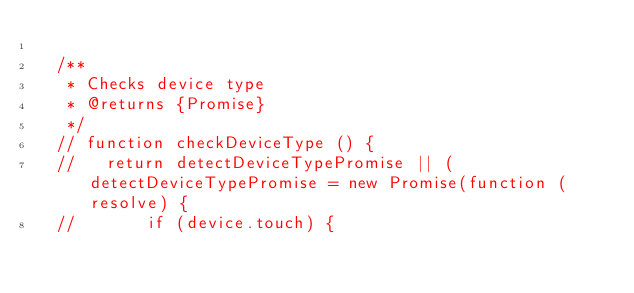<code> <loc_0><loc_0><loc_500><loc_500><_JavaScript_>
  /**
   * Checks device type
   * @returns {Promise}
   */
  // function checkDeviceType () {
  //   return detectDeviceTypePromise || (detectDeviceTypePromise = new Promise(function (resolve) {
  //       if (device.touch) {</code> 